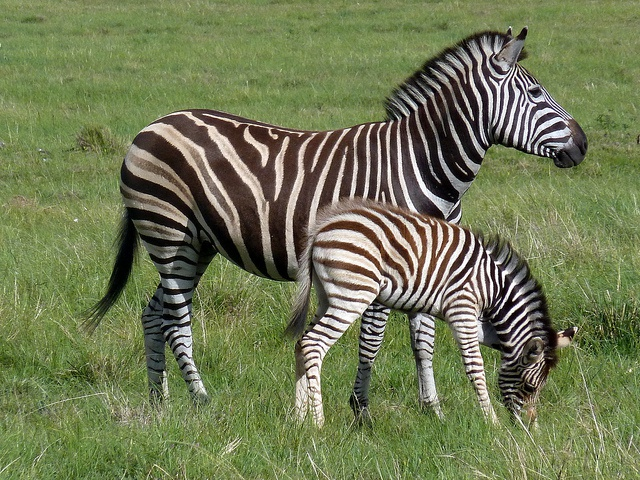Describe the objects in this image and their specific colors. I can see zebra in olive, black, gray, and lightgray tones and zebra in olive, lightgray, black, gray, and darkgray tones in this image. 